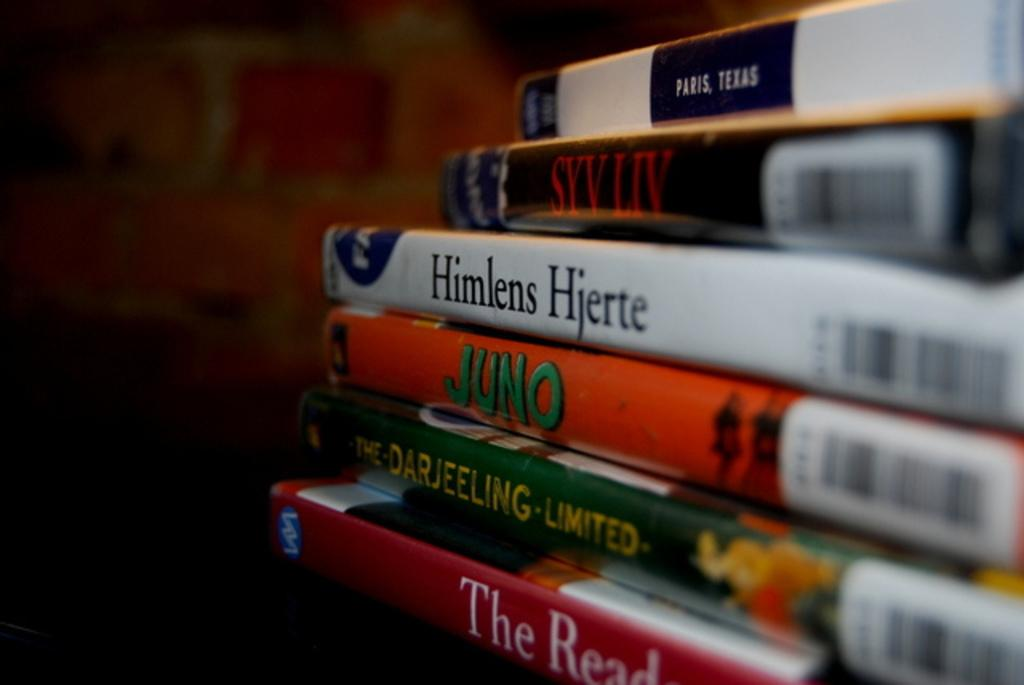<image>
Create a compact narrative representing the image presented. A stack of DVDs including The Darjeeling Limited 